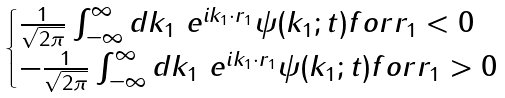Convert formula to latex. <formula><loc_0><loc_0><loc_500><loc_500>\begin{cases} \frac { 1 } { \sqrt { 2 \pi } } \int ^ { \infty } _ { - \infty } d k _ { 1 } \ e ^ { i k _ { 1 } \cdot r _ { 1 } } \psi ( k _ { 1 } ; t ) f o r r _ { 1 } < 0 \\ - \frac { 1 } { \sqrt { 2 \pi } } \int ^ { \infty } _ { - \infty } d k _ { 1 } \ e ^ { i k _ { 1 } \cdot r _ { 1 } } \psi ( k _ { 1 } ; t ) f o r r _ { 1 } > 0 \end{cases}</formula> 